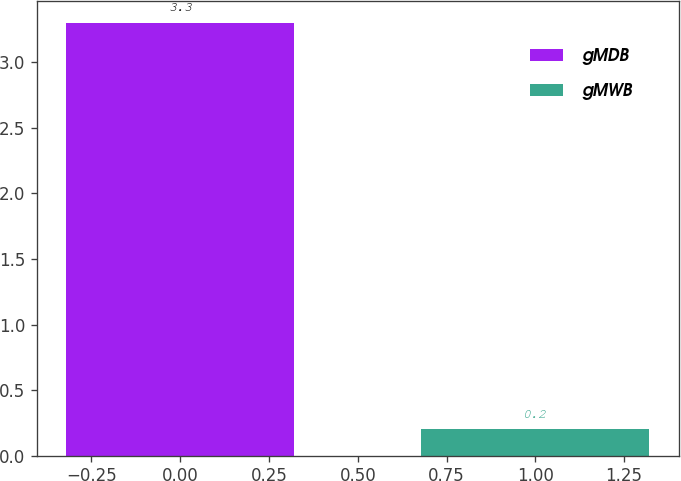Convert chart. <chart><loc_0><loc_0><loc_500><loc_500><bar_chart><fcel>gMDB<fcel>gMWB<nl><fcel>3.3<fcel>0.2<nl></chart> 